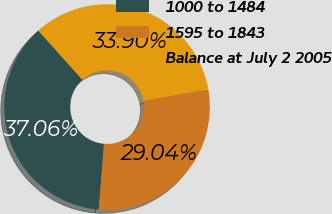Convert chart. <chart><loc_0><loc_0><loc_500><loc_500><pie_chart><fcel>1000 to 1484<fcel>1595 to 1843<fcel>Balance at July 2 2005<nl><fcel>37.06%<fcel>29.04%<fcel>33.9%<nl></chart> 